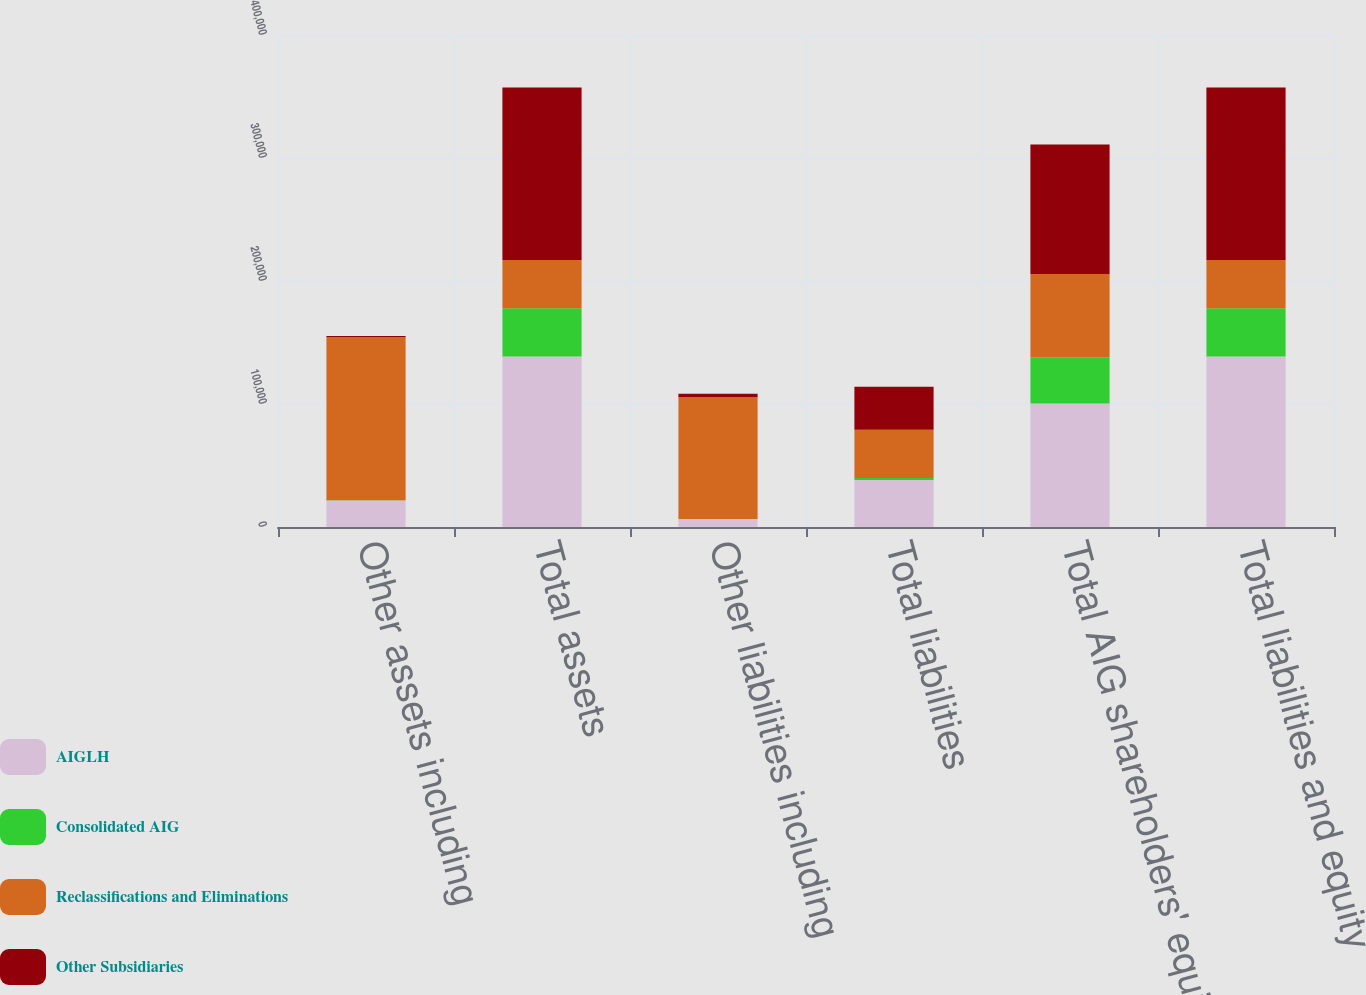<chart> <loc_0><loc_0><loc_500><loc_500><stacked_bar_chart><ecel><fcel>Other assets including<fcel>Total assets<fcel>Other liabilities including<fcel>Total liabilities<fcel>Total AIG shareholders' equity<fcel>Total liabilities and equity<nl><fcel>AIGLH<fcel>21606<fcel>138583<fcel>6422<fcel>38113<fcel>100470<fcel>138583<nl><fcel>Consolidated AIG<fcel>112<fcel>39266<fcel>161<fcel>1713<fcel>37553<fcel>39266<nl><fcel>Reclassifications and Eliminations<fcel>132492<fcel>39266<fcel>98908<fcel>39266<fcel>67672<fcel>39266<nl><fcel>Other Subsidiaries<fcel>1086<fcel>140216<fcel>2766<fcel>34991<fcel>105225<fcel>140216<nl></chart> 